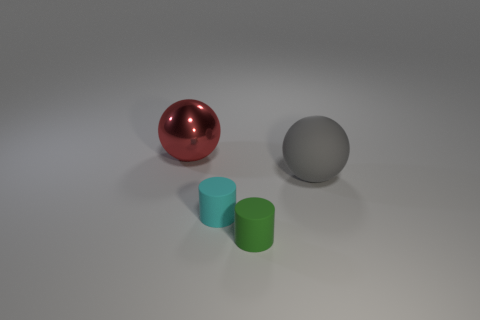Can you describe the arrangement and colors of the objects in the image? Certainly! In the image, there are three objects: a shiny red sphere, a large matte gray sphere, and two cylinders, one cyan and one green. The red sphere is positioned in front of the gray sphere, while the two cylinders are to the front left of the gray sphere, next to each other, with the cyan cylinder closer to the gray sphere than the green one. 